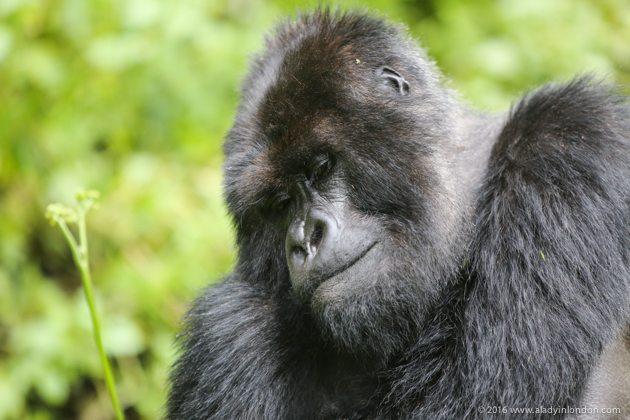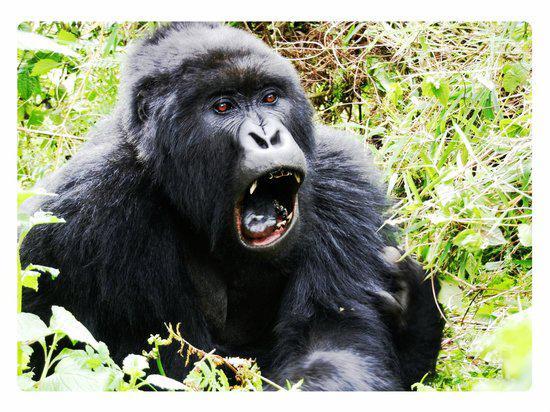The first image is the image on the left, the second image is the image on the right. For the images displayed, is the sentence "The right image features an adult gorilla peering leftward with a closed mouth." factually correct? Answer yes or no. No. The first image is the image on the left, the second image is the image on the right. Considering the images on both sides, is "A single primate is in the grass in each of the images." valid? Answer yes or no. Yes. 